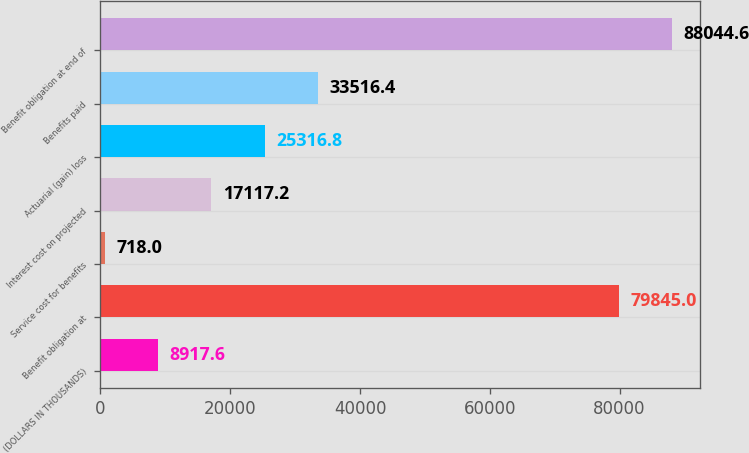Convert chart. <chart><loc_0><loc_0><loc_500><loc_500><bar_chart><fcel>(DOLLARS IN THOUSANDS)<fcel>Benefit obligation at<fcel>Service cost for benefits<fcel>Interest cost on projected<fcel>Actuarial (gain) loss<fcel>Benefits paid<fcel>Benefit obligation at end of<nl><fcel>8917.6<fcel>79845<fcel>718<fcel>17117.2<fcel>25316.8<fcel>33516.4<fcel>88044.6<nl></chart> 